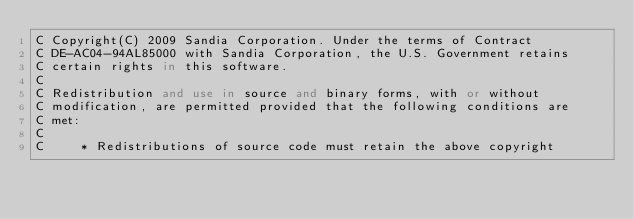<code> <loc_0><loc_0><loc_500><loc_500><_FORTRAN_>C Copyright(C) 2009 Sandia Corporation. Under the terms of Contract
C DE-AC04-94AL85000 with Sandia Corporation, the U.S. Government retains
C certain rights in this software.
C         
C Redistribution and use in source and binary forms, with or without
C modification, are permitted provided that the following conditions are
C met:
C 
C     * Redistributions of source code must retain the above copyright</code> 